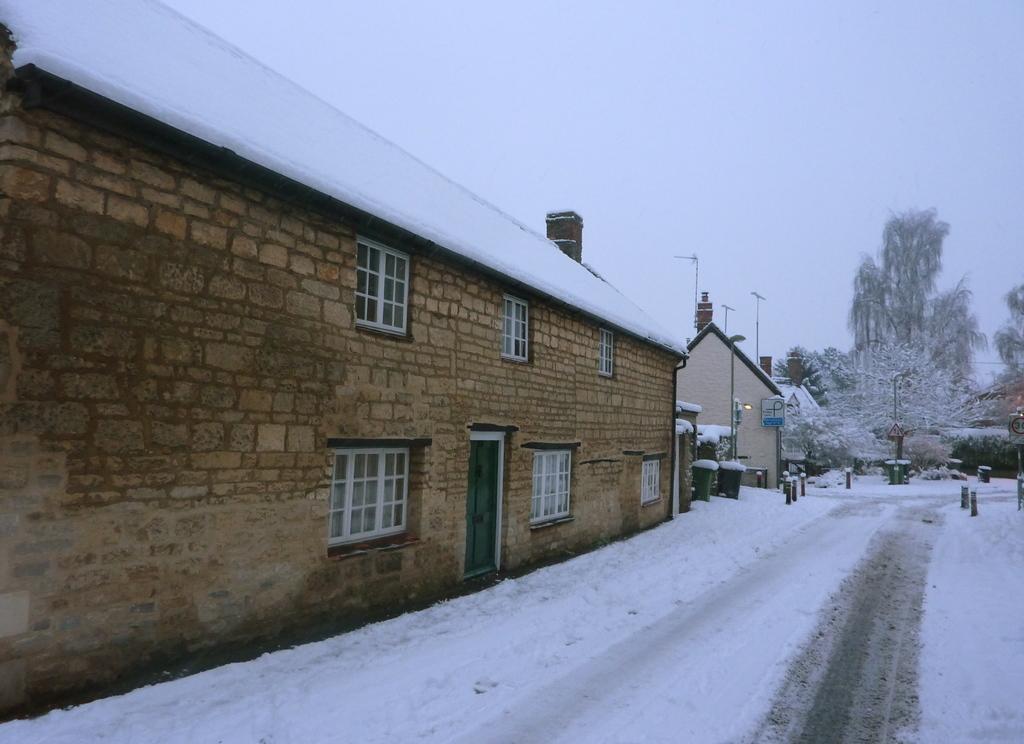How would you summarize this image in a sentence or two? In this picture we can see snow, houses, poles, lights and dustbins. In the background of the image we can see trees and sky. 